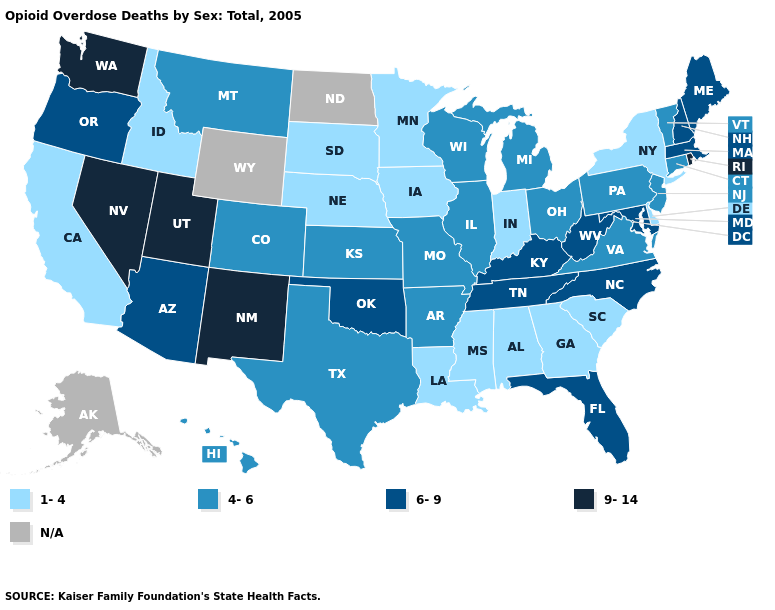What is the highest value in states that border Minnesota?
Be succinct. 4-6. Does Utah have the highest value in the West?
Quick response, please. Yes. How many symbols are there in the legend?
Concise answer only. 5. Which states have the lowest value in the West?
Concise answer only. California, Idaho. Name the states that have a value in the range 4-6?
Be succinct. Arkansas, Colorado, Connecticut, Hawaii, Illinois, Kansas, Michigan, Missouri, Montana, New Jersey, Ohio, Pennsylvania, Texas, Vermont, Virginia, Wisconsin. What is the value of Rhode Island?
Give a very brief answer. 9-14. Name the states that have a value in the range 4-6?
Give a very brief answer. Arkansas, Colorado, Connecticut, Hawaii, Illinois, Kansas, Michigan, Missouri, Montana, New Jersey, Ohio, Pennsylvania, Texas, Vermont, Virginia, Wisconsin. Which states have the lowest value in the West?
Keep it brief. California, Idaho. What is the highest value in the USA?
Concise answer only. 9-14. Which states have the lowest value in the USA?
Be succinct. Alabama, California, Delaware, Georgia, Idaho, Indiana, Iowa, Louisiana, Minnesota, Mississippi, Nebraska, New York, South Carolina, South Dakota. Among the states that border New York , which have the lowest value?
Quick response, please. Connecticut, New Jersey, Pennsylvania, Vermont. Name the states that have a value in the range 1-4?
Quick response, please. Alabama, California, Delaware, Georgia, Idaho, Indiana, Iowa, Louisiana, Minnesota, Mississippi, Nebraska, New York, South Carolina, South Dakota. Among the states that border Illinois , does Iowa have the highest value?
Write a very short answer. No. Which states have the highest value in the USA?
Answer briefly. Nevada, New Mexico, Rhode Island, Utah, Washington. What is the value of Vermont?
Concise answer only. 4-6. 